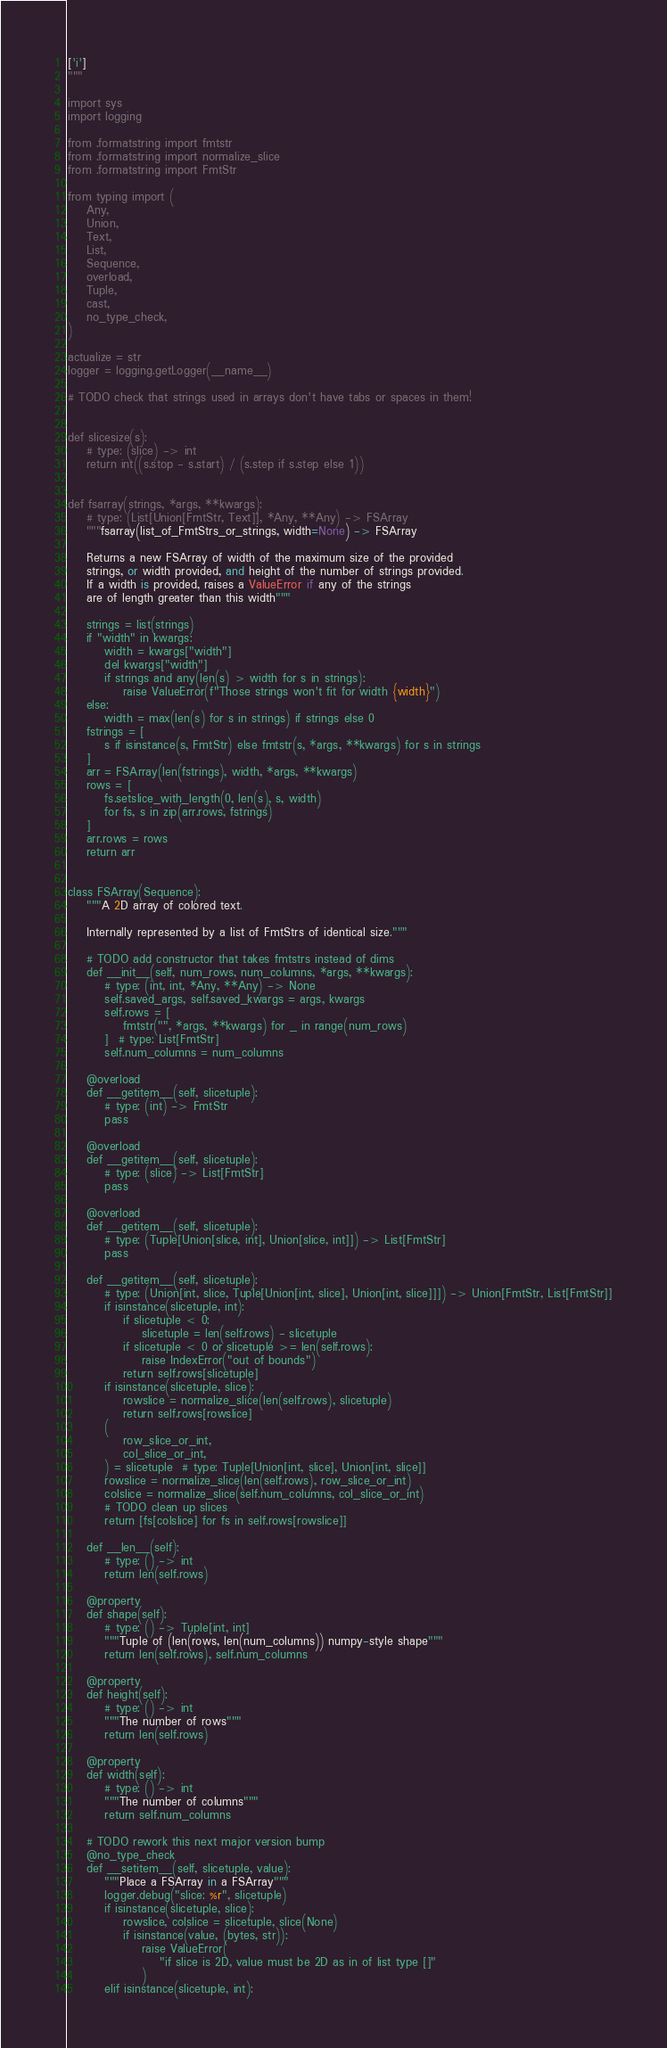<code> <loc_0><loc_0><loc_500><loc_500><_Python_>['i']
"""

import sys
import logging

from .formatstring import fmtstr
from .formatstring import normalize_slice
from .formatstring import FmtStr

from typing import (
    Any,
    Union,
    Text,
    List,
    Sequence,
    overload,
    Tuple,
    cast,
    no_type_check,
)

actualize = str
logger = logging.getLogger(__name__)

# TODO check that strings used in arrays don't have tabs or spaces in them!


def slicesize(s):
    # type: (slice) -> int
    return int((s.stop - s.start) / (s.step if s.step else 1))


def fsarray(strings, *args, **kwargs):
    # type: (List[Union[FmtStr, Text]], *Any, **Any) -> FSArray
    """fsarray(list_of_FmtStrs_or_strings, width=None) -> FSArray

    Returns a new FSArray of width of the maximum size of the provided
    strings, or width provided, and height of the number of strings provided.
    If a width is provided, raises a ValueError if any of the strings
    are of length greater than this width"""

    strings = list(strings)
    if "width" in kwargs:
        width = kwargs["width"]
        del kwargs["width"]
        if strings and any(len(s) > width for s in strings):
            raise ValueError(f"Those strings won't fit for width {width}")
    else:
        width = max(len(s) for s in strings) if strings else 0
    fstrings = [
        s if isinstance(s, FmtStr) else fmtstr(s, *args, **kwargs) for s in strings
    ]
    arr = FSArray(len(fstrings), width, *args, **kwargs)
    rows = [
        fs.setslice_with_length(0, len(s), s, width)
        for fs, s in zip(arr.rows, fstrings)
    ]
    arr.rows = rows
    return arr


class FSArray(Sequence):
    """A 2D array of colored text.

    Internally represented by a list of FmtStrs of identical size."""

    # TODO add constructor that takes fmtstrs instead of dims
    def __init__(self, num_rows, num_columns, *args, **kwargs):
        # type: (int, int, *Any, **Any) -> None
        self.saved_args, self.saved_kwargs = args, kwargs
        self.rows = [
            fmtstr("", *args, **kwargs) for _ in range(num_rows)
        ]  # type: List[FmtStr]
        self.num_columns = num_columns

    @overload
    def __getitem__(self, slicetuple):
        # type: (int) -> FmtStr
        pass

    @overload
    def __getitem__(self, slicetuple):
        # type: (slice) -> List[FmtStr]
        pass

    @overload
    def __getitem__(self, slicetuple):
        # type: (Tuple[Union[slice, int], Union[slice, int]]) -> List[FmtStr]
        pass

    def __getitem__(self, slicetuple):
        # type: (Union[int, slice, Tuple[Union[int, slice], Union[int, slice]]]) -> Union[FmtStr, List[FmtStr]]
        if isinstance(slicetuple, int):
            if slicetuple < 0:
                slicetuple = len(self.rows) - slicetuple
            if slicetuple < 0 or slicetuple >= len(self.rows):
                raise IndexError("out of bounds")
            return self.rows[slicetuple]
        if isinstance(slicetuple, slice):
            rowslice = normalize_slice(len(self.rows), slicetuple)
            return self.rows[rowslice]
        (
            row_slice_or_int,
            col_slice_or_int,
        ) = slicetuple  # type: Tuple[Union[int, slice], Union[int, slice]]
        rowslice = normalize_slice(len(self.rows), row_slice_or_int)
        colslice = normalize_slice(self.num_columns, col_slice_or_int)
        # TODO clean up slices
        return [fs[colslice] for fs in self.rows[rowslice]]

    def __len__(self):
        # type: () -> int
        return len(self.rows)

    @property
    def shape(self):
        # type: () -> Tuple[int, int]
        """Tuple of (len(rows, len(num_columns)) numpy-style shape"""
        return len(self.rows), self.num_columns

    @property
    def height(self):
        # type: () -> int
        """The number of rows"""
        return len(self.rows)

    @property
    def width(self):
        # type: () -> int
        """The number of columns"""
        return self.num_columns

    # TODO rework this next major version bump
    @no_type_check
    def __setitem__(self, slicetuple, value):
        """Place a FSArray in a FSArray"""
        logger.debug("slice: %r", slicetuple)
        if isinstance(slicetuple, slice):
            rowslice, colslice = slicetuple, slice(None)
            if isinstance(value, (bytes, str)):
                raise ValueError(
                    "if slice is 2D, value must be 2D as in of list type []"
                )
        elif isinstance(slicetuple, int):</code> 